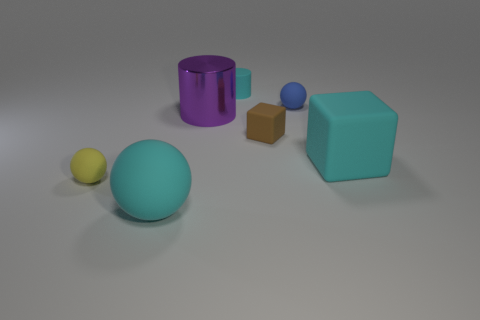Subtract all red blocks. Subtract all green cylinders. How many blocks are left? 2 Add 3 tiny brown cylinders. How many objects exist? 10 Subtract all cylinders. How many objects are left? 5 Add 1 blue matte spheres. How many blue matte spheres exist? 2 Subtract 0 yellow cylinders. How many objects are left? 7 Subtract all brown matte cylinders. Subtract all blue matte objects. How many objects are left? 6 Add 6 small brown objects. How many small brown objects are left? 7 